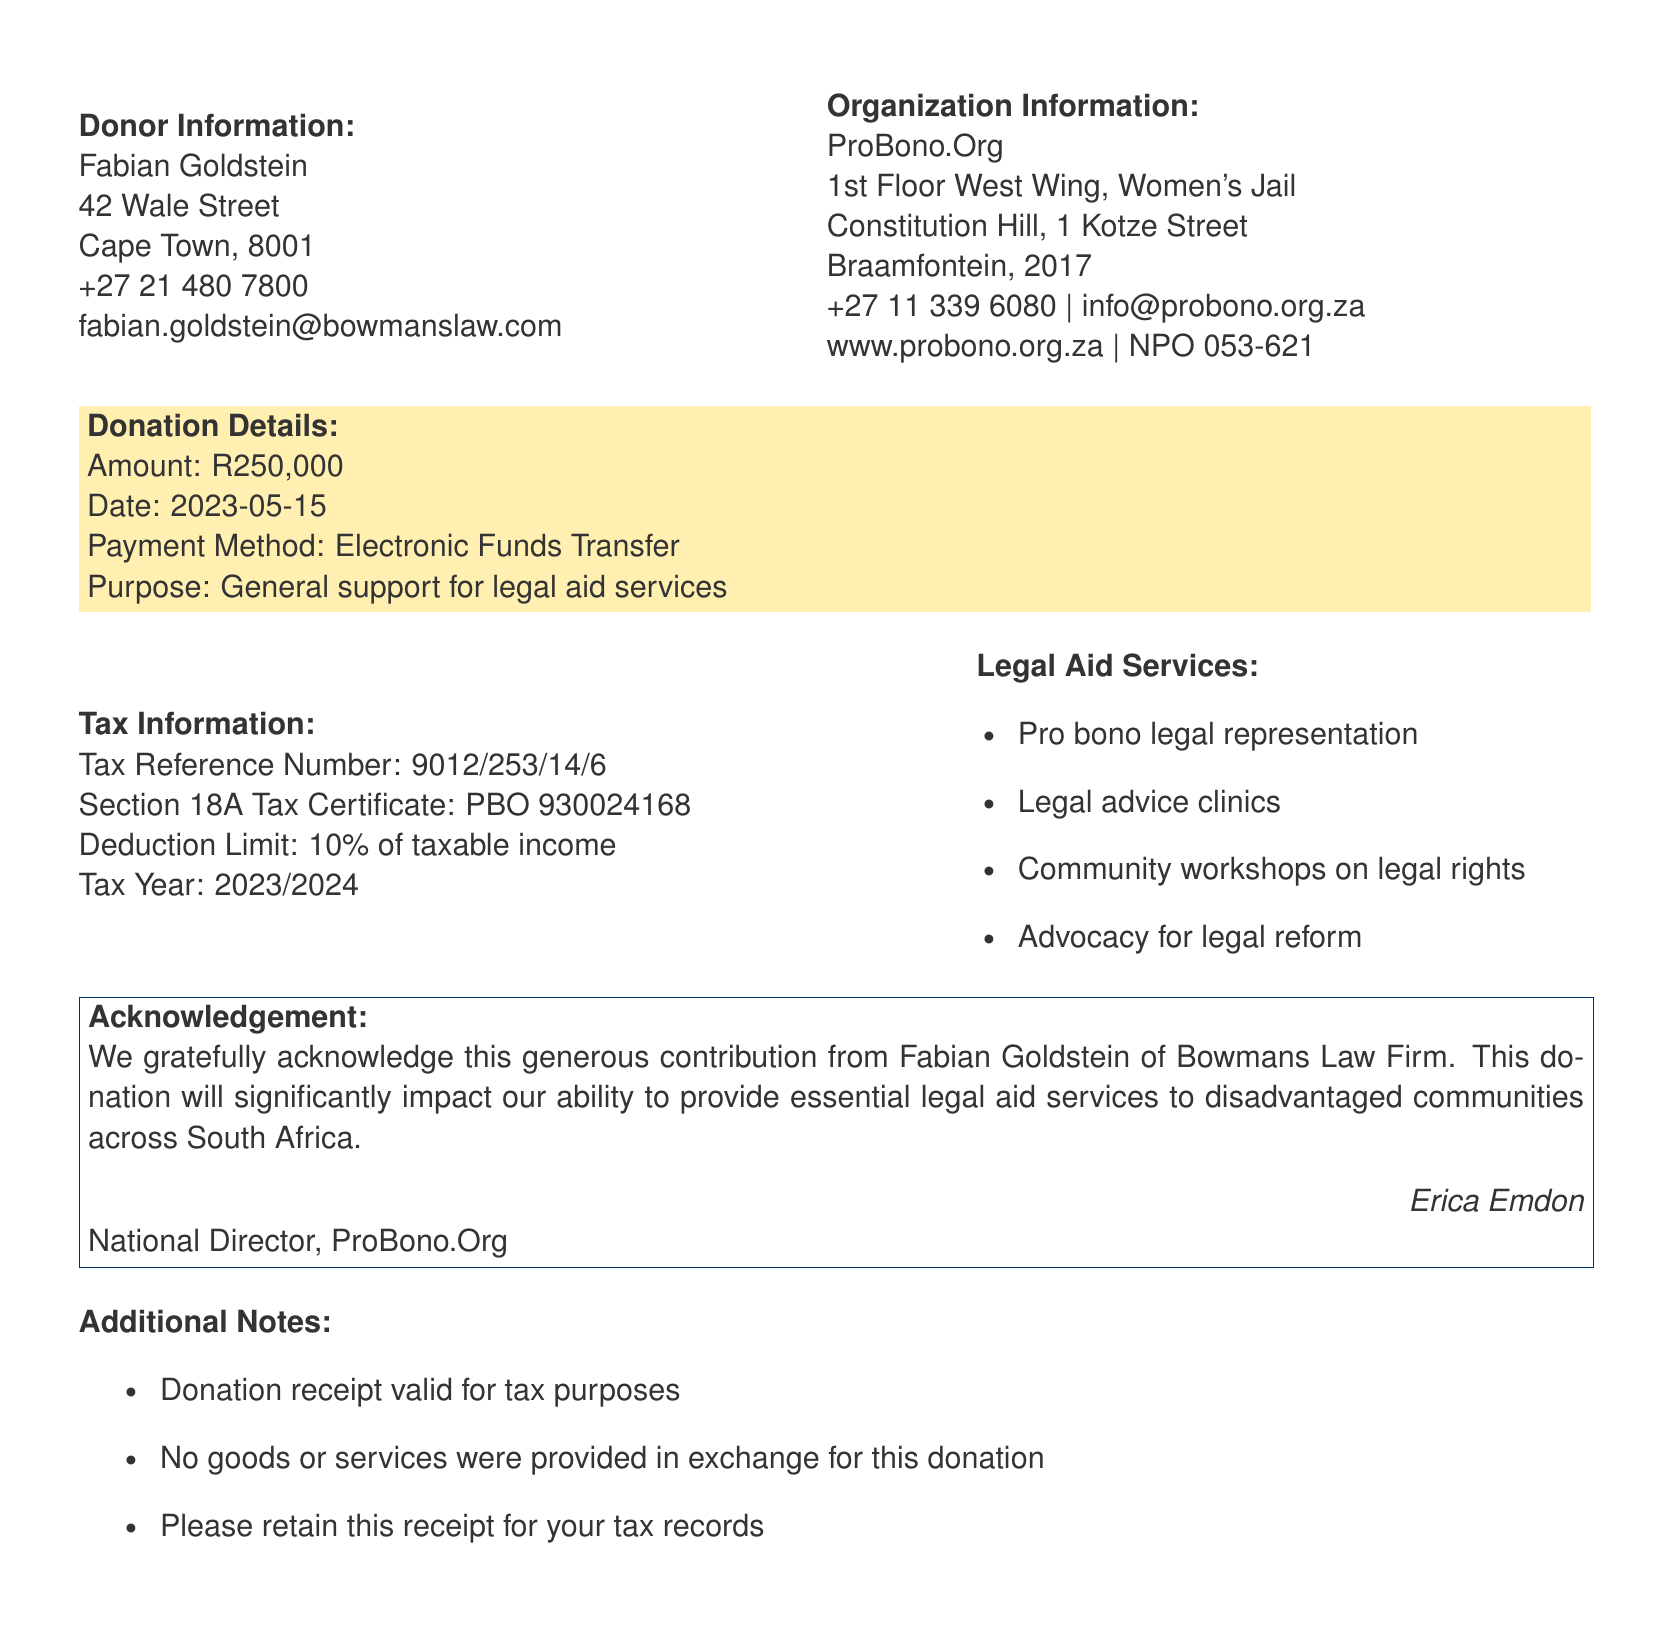What is the donor's name? The donor's name is presented at the beginning of the document under Donor Information.
Answer: Fabian Goldstein What is the donation amount? The donation amount is stated clearly under Donation Details.
Answer: R250,000 Who is the signatory of the acknowledgment? The signatory's name is found in the Acknowledgement section of the document.
Answer: Erica Emdon What is the purpose of the donation? The purpose of the donation is specified in the Donation Details section.
Answer: General support for legal aid services What is the tax reference number? The tax reference number is provided in the Tax Information section.
Answer: 9012/253/14/6 What is the organization’s registration number? The registration number of the organization is stated in the Organization Information.
Answer: NPO 053-621 What services are offered by the legal aid organization? The services are listed in the Legal Aid Services section.
Answer: Pro bono legal representation, Legal advice clinics, Community workshops on legal rights, Advocacy for legal reform What is the tax year for the deduction limit? The tax year is mentioned in the Tax Information section of the document.
Answer: 2023/2024 Is the donation receipt valid for tax purposes? This is noted in the Additional Notes section of the document, confirming the receipt's validity.
Answer: Yes 